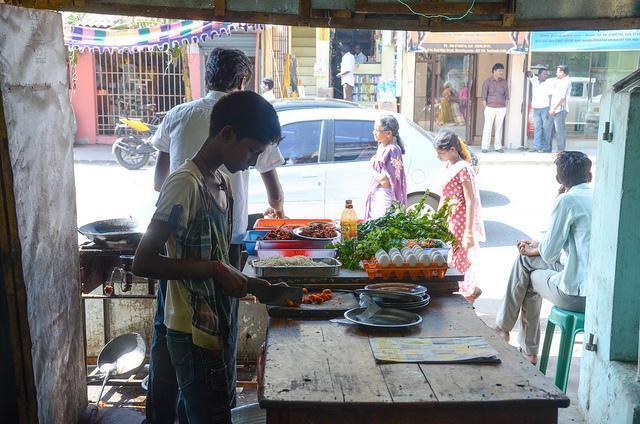How many books can be seen?
Give a very brief answer. 1. How many people are there?
Give a very brief answer. 5. How many dining tables are in the picture?
Give a very brief answer. 2. 